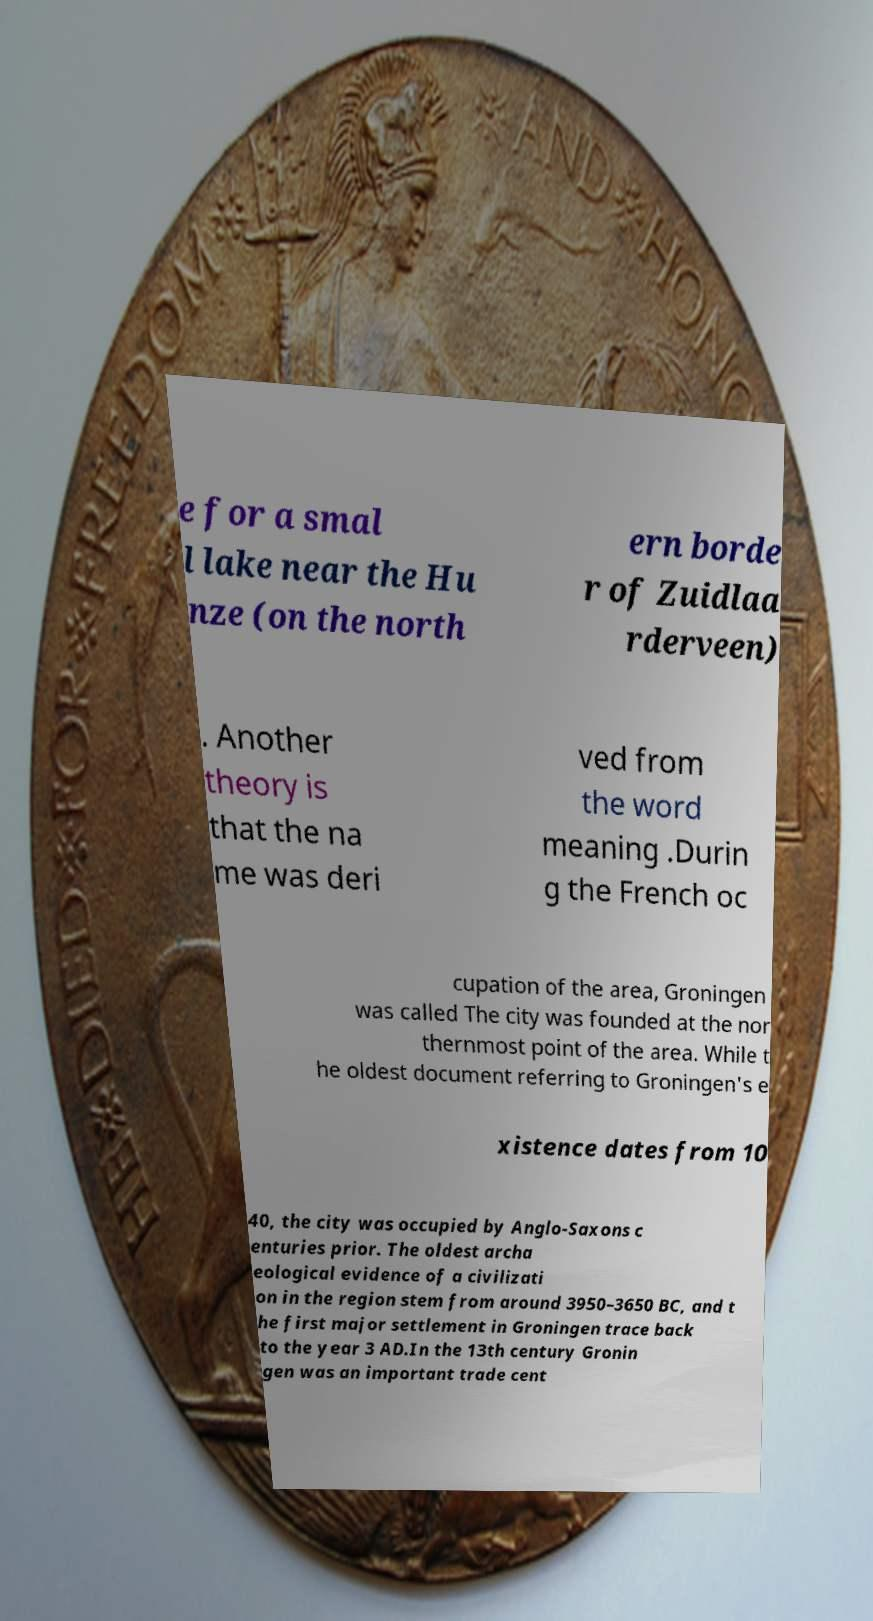For documentation purposes, I need the text within this image transcribed. Could you provide that? e for a smal l lake near the Hu nze (on the north ern borde r of Zuidlaa rderveen) . Another theory is that the na me was deri ved from the word meaning .Durin g the French oc cupation of the area, Groningen was called The city was founded at the nor thernmost point of the area. While t he oldest document referring to Groningen's e xistence dates from 10 40, the city was occupied by Anglo-Saxons c enturies prior. The oldest archa eological evidence of a civilizati on in the region stem from around 3950–3650 BC, and t he first major settlement in Groningen trace back to the year 3 AD.In the 13th century Gronin gen was an important trade cent 